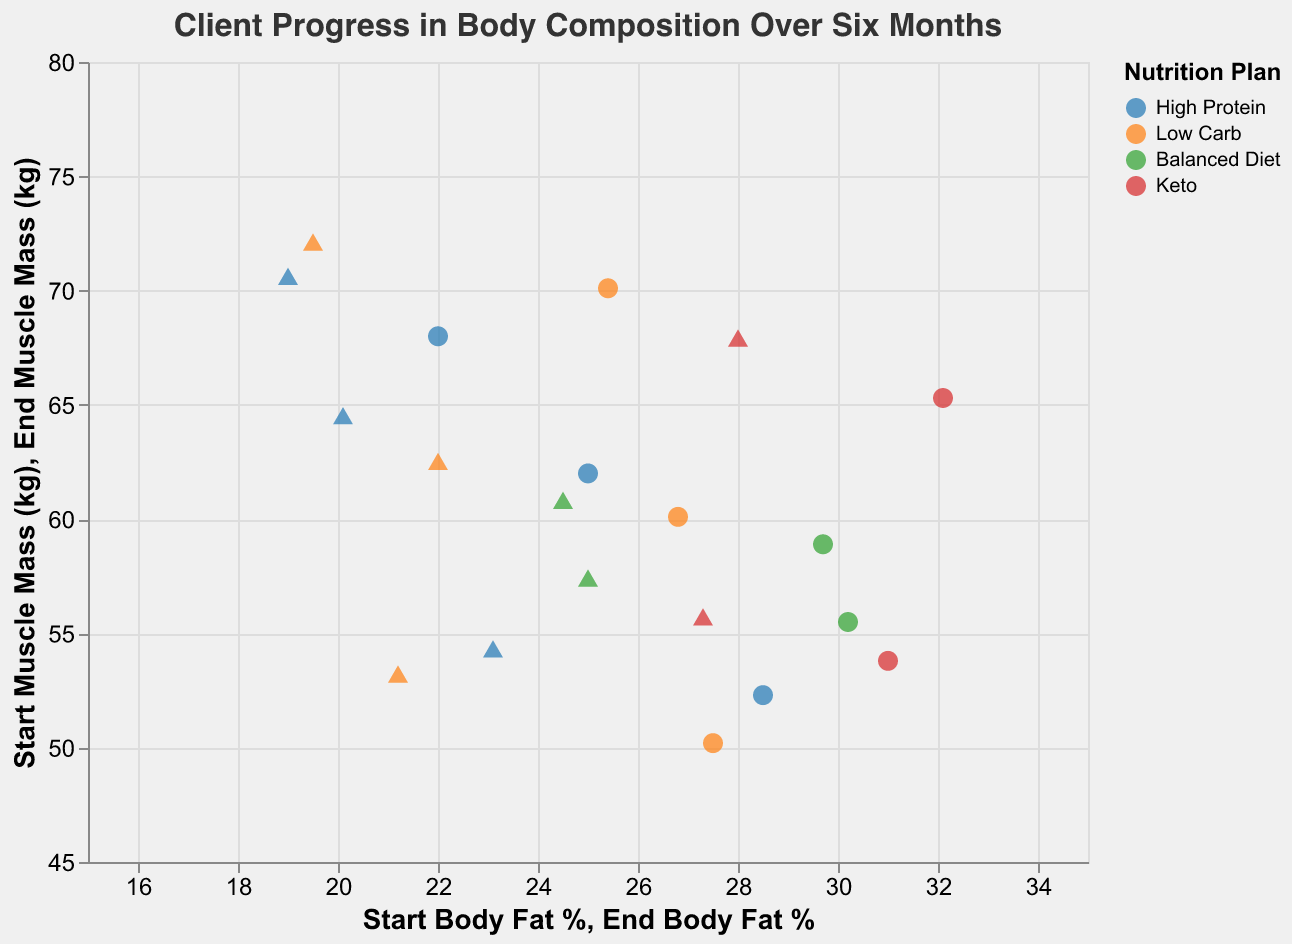What's the title of the figure? The title of the figure is usually positioned at the top. In this case, it is "Client Progress in Body Composition Over Six Months".
Answer: Client Progress in Body Composition Over Six Months What are the different types of nutrition plans shown in the figure? The nutrition plans are differentiated by colors in the scatter plot. According to the legend, the different types are High Protein, Low Carb, Balanced Diet, and Keto.
Answer: High Protein, Low Carb, Balanced Diet, Keto What does the circle shape represent in the scatter plot? In the legend, it indicates that circles represent the initial (start) body composition metrics.
Answer: Start body composition metrics Which client had the highest end muscle mass? By looking at the end muscle mass points (triangles) on the y-axis, the highest point corresponds to Bob Smith with an end muscle mass of 72.0 kg.
Answer: Bob Smith What color represents the High Protein nutrition plan? The legend shows that blue represents the High Protein nutrition plan.
Answer: Blue Which nutrition plan showed the greatest reduction in body fat percentage on average? To determine this, calculate the reduction for each client under each plan and find the average for each plan:
- High Protein: (28.5-23.1)+ (22.0-19.0) + (25.0-20.1)/3 = 4.8
- Low Carb: (25.4-19.5)+ (27.5-21.2)+ (26.8-22.0)/3 = 6
- Balanced Diet: (30.2-25.0) + (29.7-24.5) / 2 = 5.2
- Keto: (32.1-28.0) + (31.0-27.3) / 2 = 3.9
Low Carb has the highest average reduction.
Answer: Low Carb How many data points are there for each nutrition plan? Each nutrition plan color corresponds with a specific number of points. By counting, we have:
- High Protein: 3 clients (Alice Johnson, David Kim, Harry Lewis)
- Low Carb: 3 clients (Bob Smith, Eva Brown, Jack Walker)
- Balanced Diet: 2 clients (Carol Lee, Grace Hill)
- Keto: 2 clients (Frank White, Irene Clark)
Answer: High Protein: 3, Low Carb: 3, Balanced Diet: 2, Keto: 2 Which clients showed an increase in muscle mass? By comparing the start and end muscle mass values, the clients who show an increase are Alice Johnson (54.2-52.3), Bob Smith (72.0-70.1), Carol Lee (57.3-55.5), David Kim (70.5-68.0), Eva Brown (53.1-50.2), Frank White (67.8-65.3), Grace Hill (60.7-58.9), Harry Lewis (64.4-62.0), Irene Clark (55.6-53.8), Jack Walker (62.4-60.1). All clients showed an increase in muscle mass.
Answer: All clients What is the range of body fat percentages at the start for the clients? The range can be determined by subtracting the minimum start body fat percentage from the maximum start body fat percentage. The values range from 22.0% (David Kim) to 32.1% (Frank White), so the range is 32.1% - 22.0% = 10.1%.
Answer: 10.1% What does the triangle shape represent in the scatter plot? According to the legend in the figure, the triangle shape represents the end (six-month follow-up) body composition metrics.
Answer: End body composition metrics 